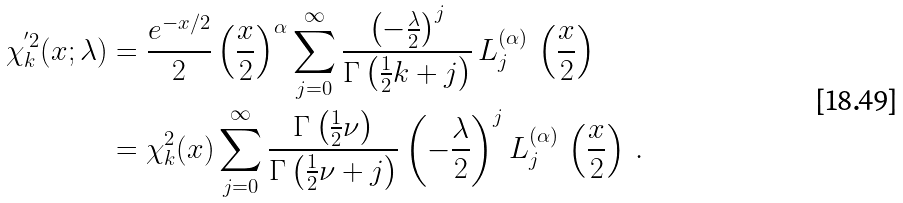Convert formula to latex. <formula><loc_0><loc_0><loc_500><loc_500>\chi _ { k } ^ { ^ { \prime } 2 } ( x ; \lambda ) & = \frac { e ^ { - x / 2 } } { 2 } \left ( \frac { x } { 2 } \right ) ^ { \alpha } \sum _ { j = 0 } ^ { \infty } \frac { \left ( - \frac { \lambda } { 2 } \right ) ^ { j } } { \Gamma \left ( \frac { 1 } { 2 } k + j \right ) } \, L _ { j } ^ { ( \alpha ) } \, \left ( \frac { x } { 2 } \right ) \\ & = \chi _ { k } ^ { 2 } ( x ) \sum _ { j = 0 } ^ { \infty } \frac { \Gamma \left ( \frac { 1 } { 2 } \nu \right ) } { \Gamma \left ( \frac { 1 } { 2 } \nu + j \right ) } \left ( - \frac { \lambda } { 2 } \right ) ^ { j } L _ { j } ^ { ( \alpha ) } \, \left ( \frac { x } { 2 } \right ) \, .</formula> 